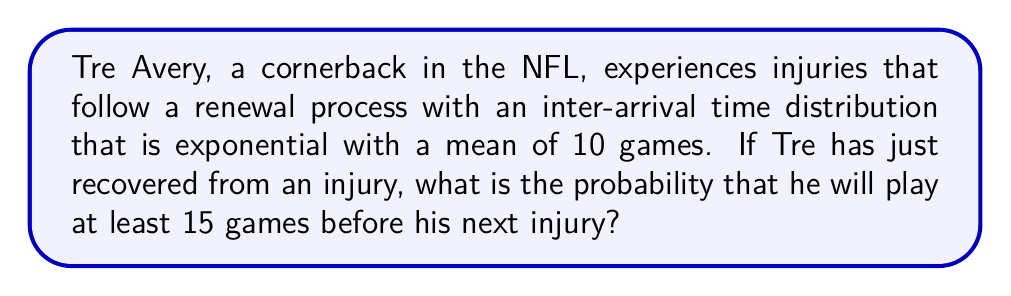Could you help me with this problem? Let's approach this step-by-step:

1) The renewal process with exponentially distributed inter-arrival times is a Poisson process.

2) Given:
   - The mean time between injuries is 10 games.
   - We want to find the probability of playing at least 15 games before the next injury.

3) For an exponential distribution with mean $\mu$, the rate parameter $\lambda = \frac{1}{\mu}$.
   Here, $\lambda = \frac{1}{10}$ per game.

4) The probability of playing at least 15 games before the next injury is equivalent to the probability that the time until the next injury is greater than 15 games.

5) For an exponential distribution, the survival function (probability of exceeding a value $t$) is given by:

   $$P(X > t) = e^{-\lambda t}$$

6) Substituting our values:

   $$P(X > 15) = e^{-\frac{1}{10} \cdot 15}$$

7) Calculating:

   $$P(X > 15) = e^{-1.5} \approx 0.2231$$

Therefore, the probability that Tre Avery will play at least 15 games before his next injury is approximately 0.2231 or 22.31%.
Answer: $e^{-1.5} \approx 0.2231$ 